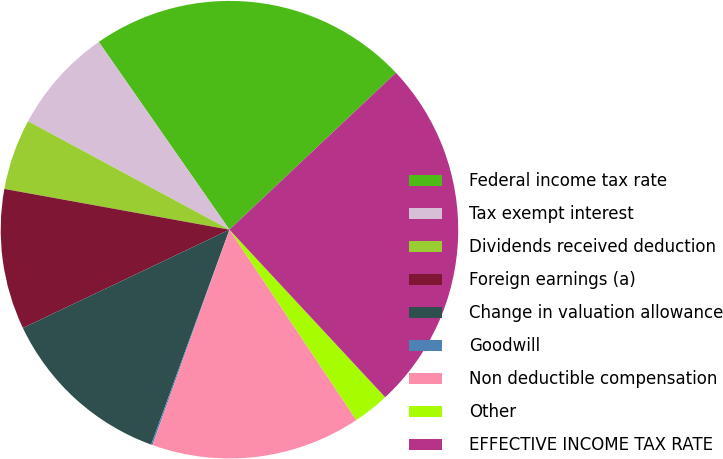Convert chart. <chart><loc_0><loc_0><loc_500><loc_500><pie_chart><fcel>Federal income tax rate<fcel>Tax exempt interest<fcel>Dividends received deduction<fcel>Foreign earnings (a)<fcel>Change in valuation allowance<fcel>Goodwill<fcel>Non deductible compensation<fcel>Other<fcel>EFFECTIVE INCOME TAX RATE<nl><fcel>22.65%<fcel>7.46%<fcel>5.01%<fcel>9.92%<fcel>12.37%<fcel>0.1%<fcel>14.82%<fcel>2.56%<fcel>25.11%<nl></chart> 